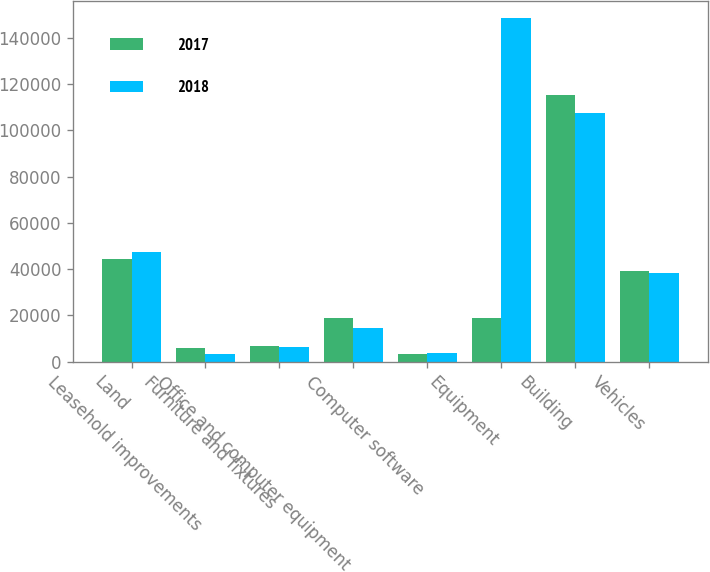<chart> <loc_0><loc_0><loc_500><loc_500><stacked_bar_chart><ecel><fcel>Land<fcel>Leasehold improvements<fcel>Furniture and fixtures<fcel>Office and computer equipment<fcel>Computer software<fcel>Equipment<fcel>Building<fcel>Vehicles<nl><fcel>2017<fcel>44261<fcel>5909<fcel>6932<fcel>18717<fcel>3278<fcel>18717<fcel>115242<fcel>39026<nl><fcel>2018<fcel>47373<fcel>3109<fcel>6461<fcel>14506<fcel>3650<fcel>148434<fcel>107374<fcel>38179<nl></chart> 